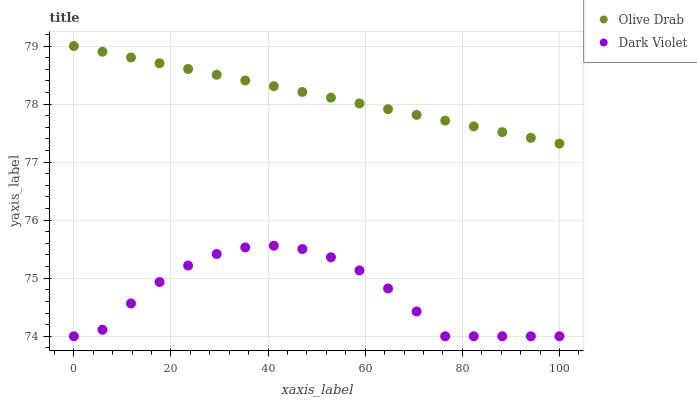Does Dark Violet have the minimum area under the curve?
Answer yes or no. Yes. Does Olive Drab have the maximum area under the curve?
Answer yes or no. Yes. Does Olive Drab have the minimum area under the curve?
Answer yes or no. No. Is Olive Drab the smoothest?
Answer yes or no. Yes. Is Dark Violet the roughest?
Answer yes or no. Yes. Is Olive Drab the roughest?
Answer yes or no. No. Does Dark Violet have the lowest value?
Answer yes or no. Yes. Does Olive Drab have the lowest value?
Answer yes or no. No. Does Olive Drab have the highest value?
Answer yes or no. Yes. Is Dark Violet less than Olive Drab?
Answer yes or no. Yes. Is Olive Drab greater than Dark Violet?
Answer yes or no. Yes. Does Dark Violet intersect Olive Drab?
Answer yes or no. No. 